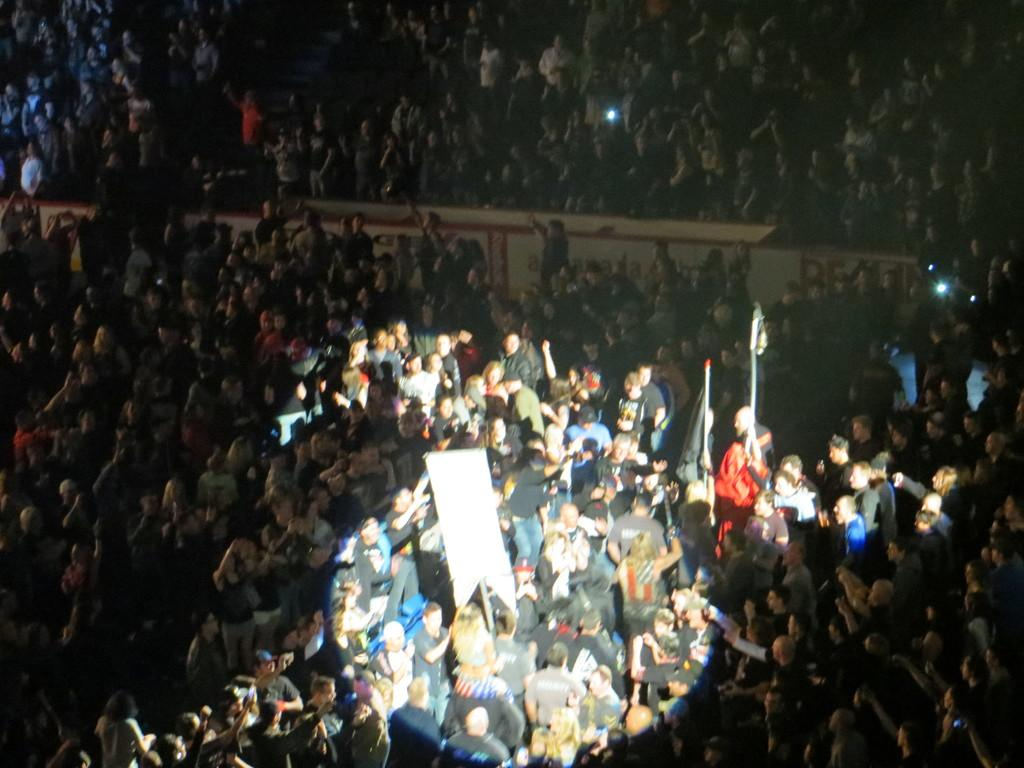How many people are in the image? There is a group of people in the image, but the exact number is not specified. What are some people doing in the image? Some people are holding flags in the image. What else can be seen in the image besides the people and flags? There are lights visible in the image. What type of breath can be seen coming from the people in the image? There is no indication of breath in the image, as it is a still photograph and not a video. 